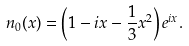Convert formula to latex. <formula><loc_0><loc_0><loc_500><loc_500>n _ { 0 } ( x ) = \left ( 1 - i x - \frac { 1 } { 3 } x ^ { 2 } \right ) e ^ { i x } .</formula> 